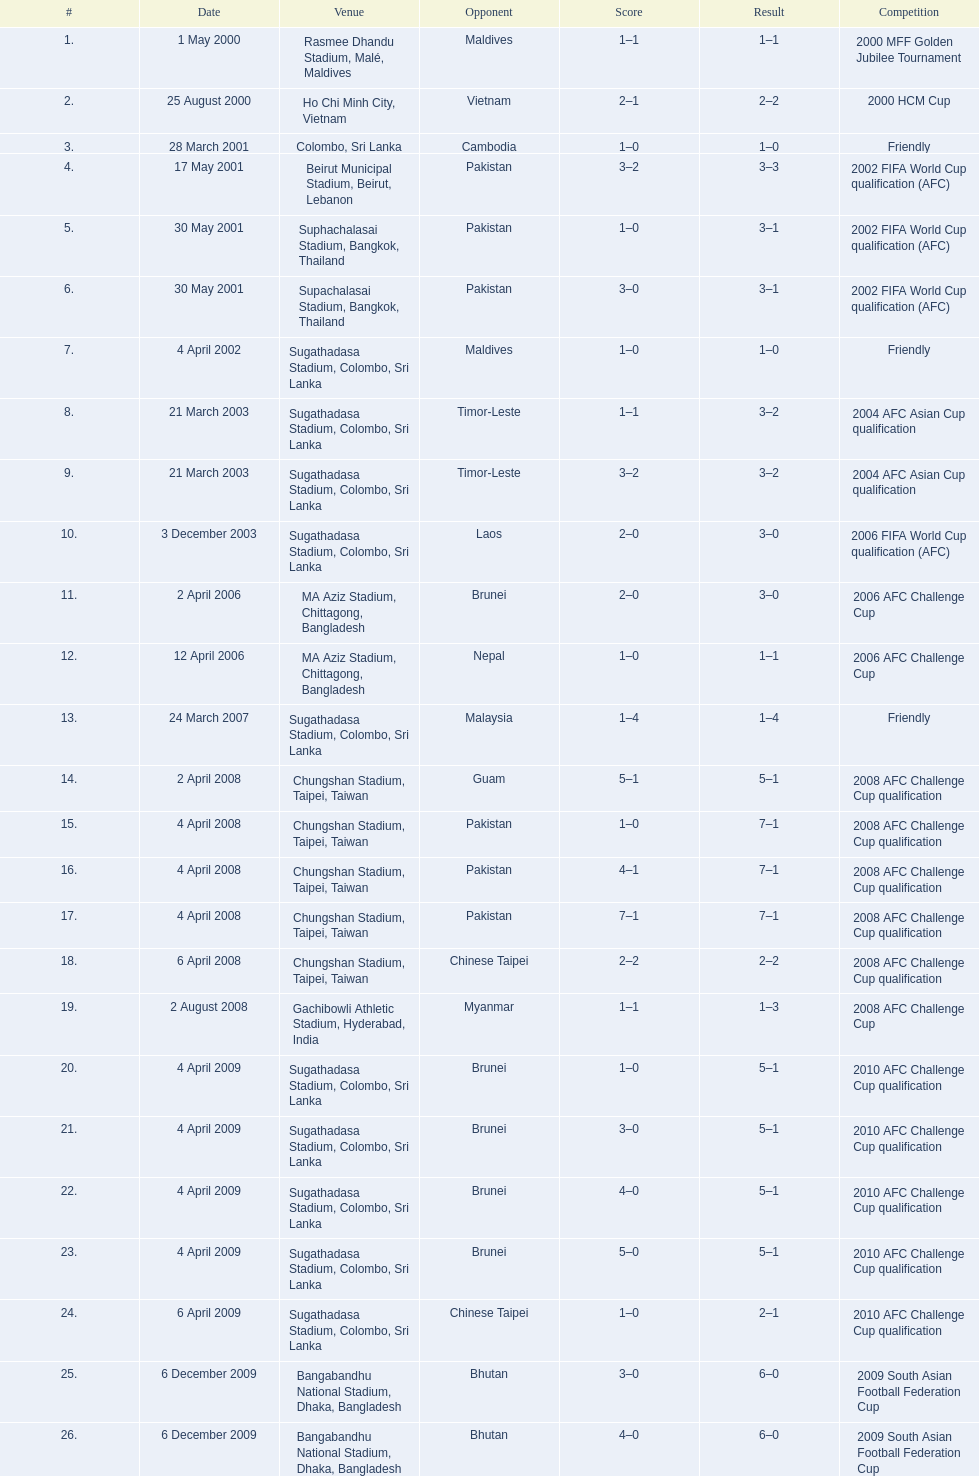Between april and december, which month had more competitions taking place? April. 